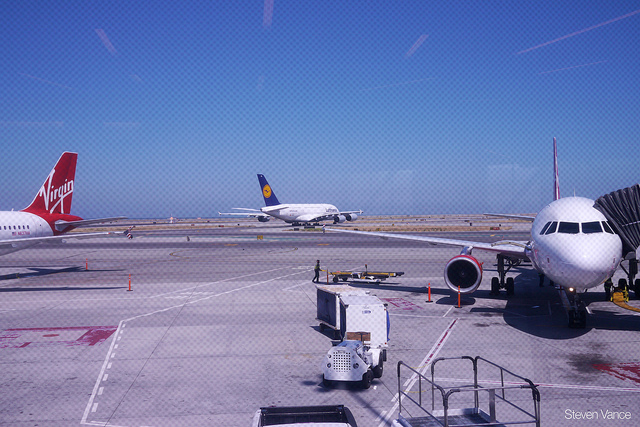Identify the text displayed in this image. Virgin Steven Vance 